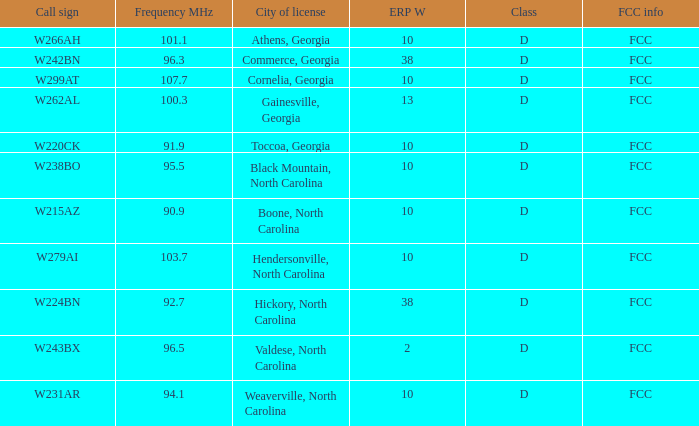Could you help me parse every detail presented in this table? {'header': ['Call sign', 'Frequency MHz', 'City of license', 'ERP W', 'Class', 'FCC info'], 'rows': [['W266AH', '101.1', 'Athens, Georgia', '10', 'D', 'FCC'], ['W242BN', '96.3', 'Commerce, Georgia', '38', 'D', 'FCC'], ['W299AT', '107.7', 'Cornelia, Georgia', '10', 'D', 'FCC'], ['W262AL', '100.3', 'Gainesville, Georgia', '13', 'D', 'FCC'], ['W220CK', '91.9', 'Toccoa, Georgia', '10', 'D', 'FCC'], ['W238BO', '95.5', 'Black Mountain, North Carolina', '10', 'D', 'FCC'], ['W215AZ', '90.9', 'Boone, North Carolina', '10', 'D', 'FCC'], ['W279AI', '103.7', 'Hendersonville, North Carolina', '10', 'D', 'FCC'], ['W224BN', '92.7', 'Hickory, North Carolina', '38', 'D', 'FCC'], ['W243BX', '96.5', 'Valdese, North Carolina', '2', 'D', 'FCC'], ['W231AR', '94.1', 'Weaverville, North Carolina', '10', 'D', 'FCC']]} What is the FCC frequency for the station w262al which has a Frequency MHz larger than 92.7? FCC. 